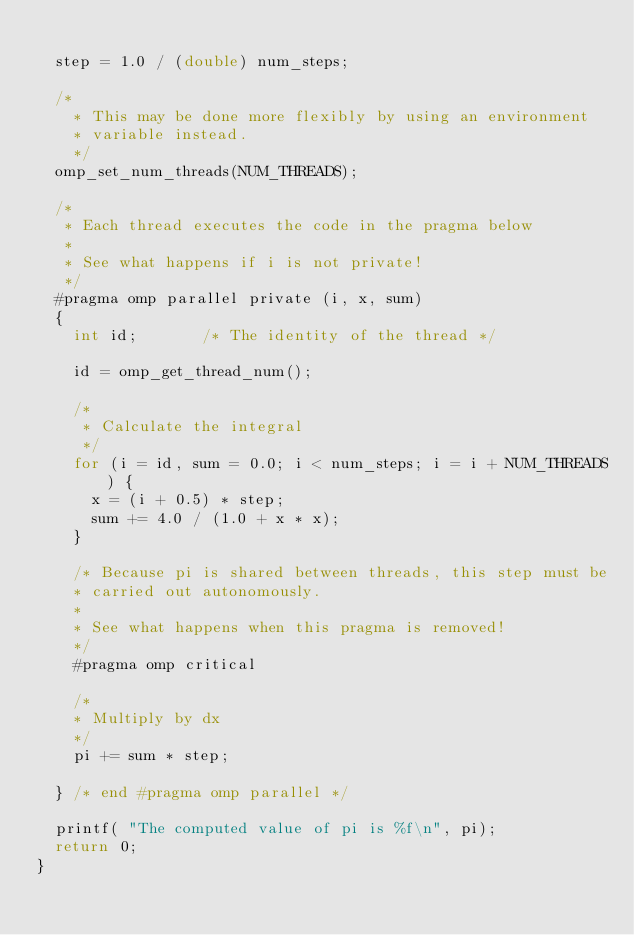<code> <loc_0><loc_0><loc_500><loc_500><_C_>
  step = 1.0 / (double) num_steps;

  /*
    * This may be done more flexibly by using an environment
    * variable instead.
    */
  omp_set_num_threads(NUM_THREADS);

  /*
   * Each thread executes the code in the pragma below
   *
   * See what happens if i is not private!
   */
  #pragma omp parallel private (i, x, sum)
  {	 
    int id;       /* The identity of the thread */

    id = omp_get_thread_num();

    /*
     * Calculate the integral
     */
    for (i = id, sum = 0.0; i < num_steps; i = i + NUM_THREADS) {
      x = (i + 0.5) * step;
      sum += 4.0 / (1.0 + x * x);
    }

    /* Because pi is shared between threads, this step must be
    * carried out autonomously.
    * 
    * See what happens when this pragma is removed!
    */
    #pragma omp critical

    /*
    * Multiply by dx
    */
    pi += sum * step;

  } /* end #pragma omp parallel */

  printf( "The computed value of pi is %f\n", pi);
  return 0;
}
</code> 